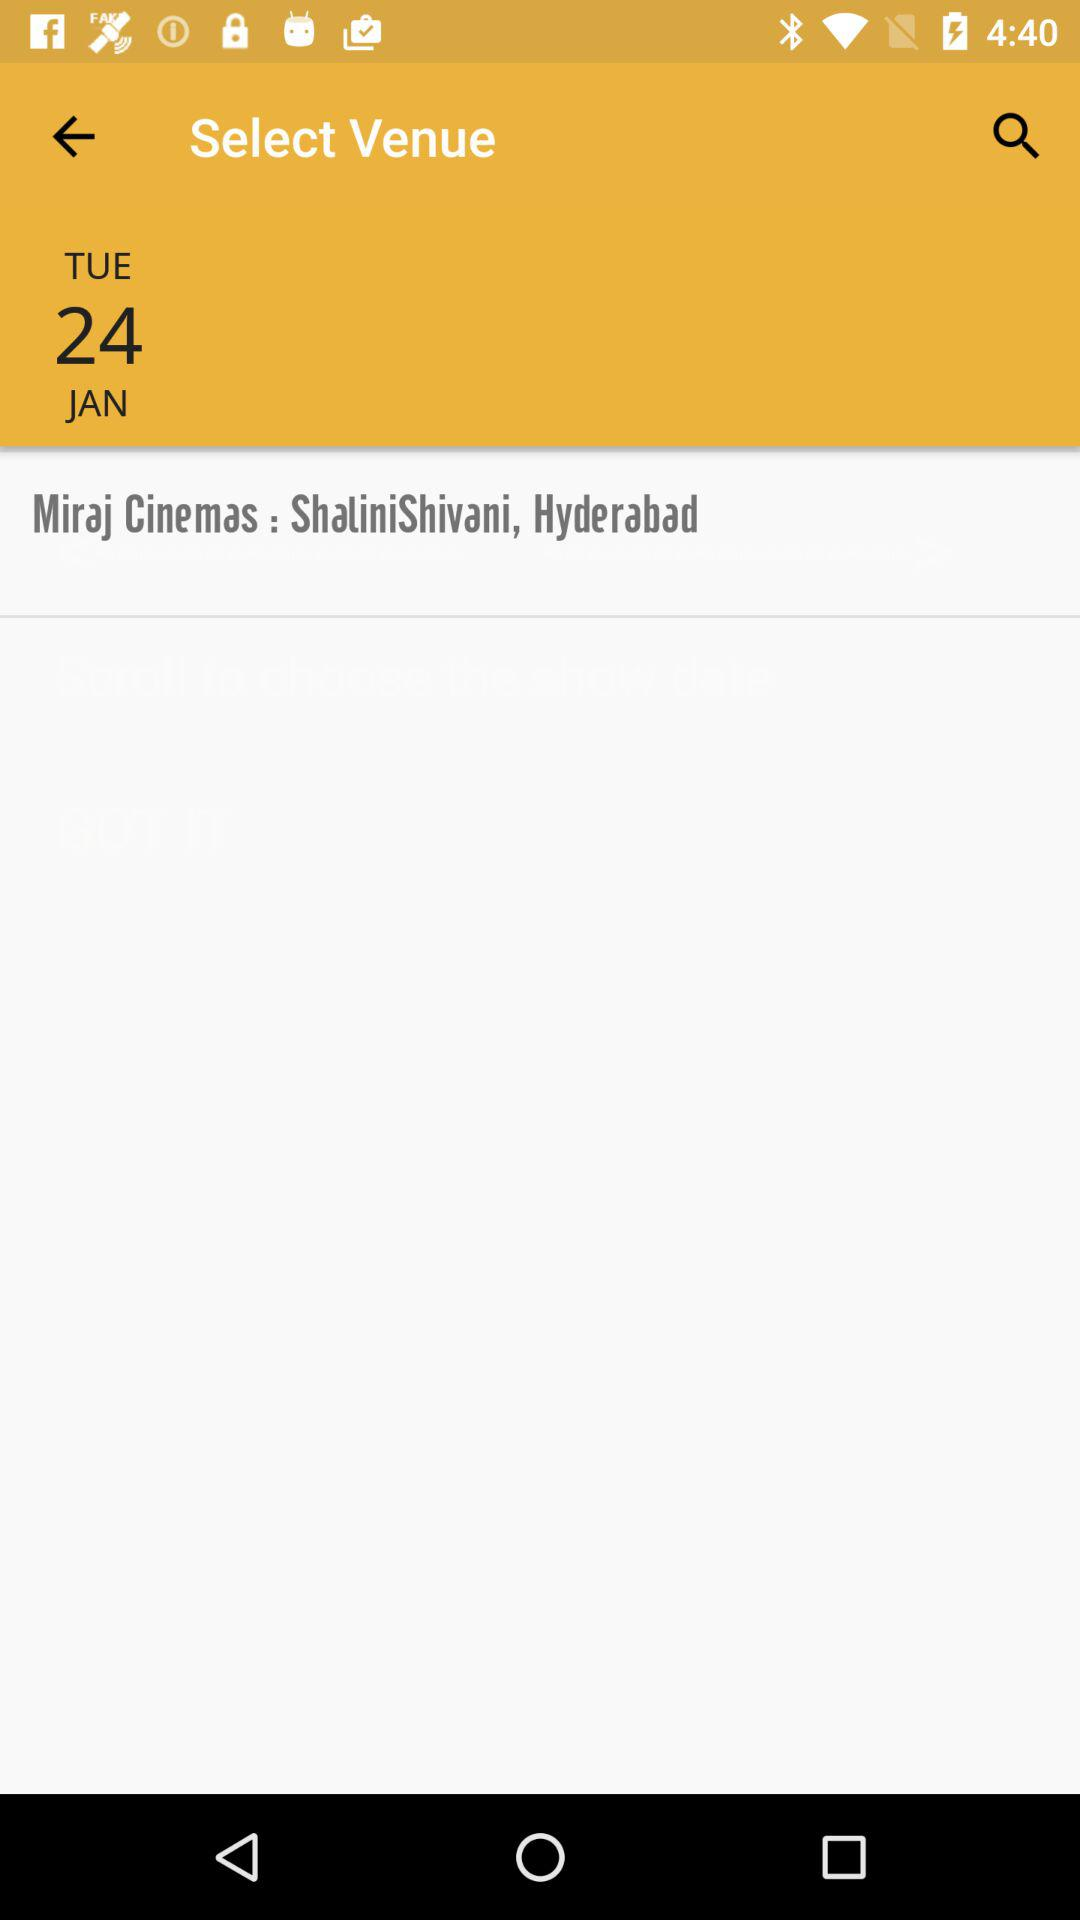What is the day on January 24? The day on January 24 is Tuesday. 